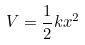<formula> <loc_0><loc_0><loc_500><loc_500>V = \frac { 1 } { 2 } k x ^ { 2 }</formula> 